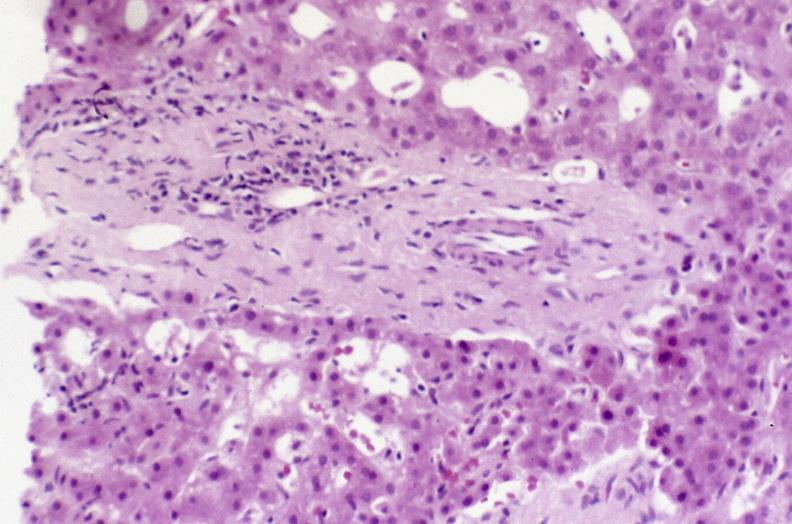s leiomyosarcoma present?
Answer the question using a single word or phrase. No 